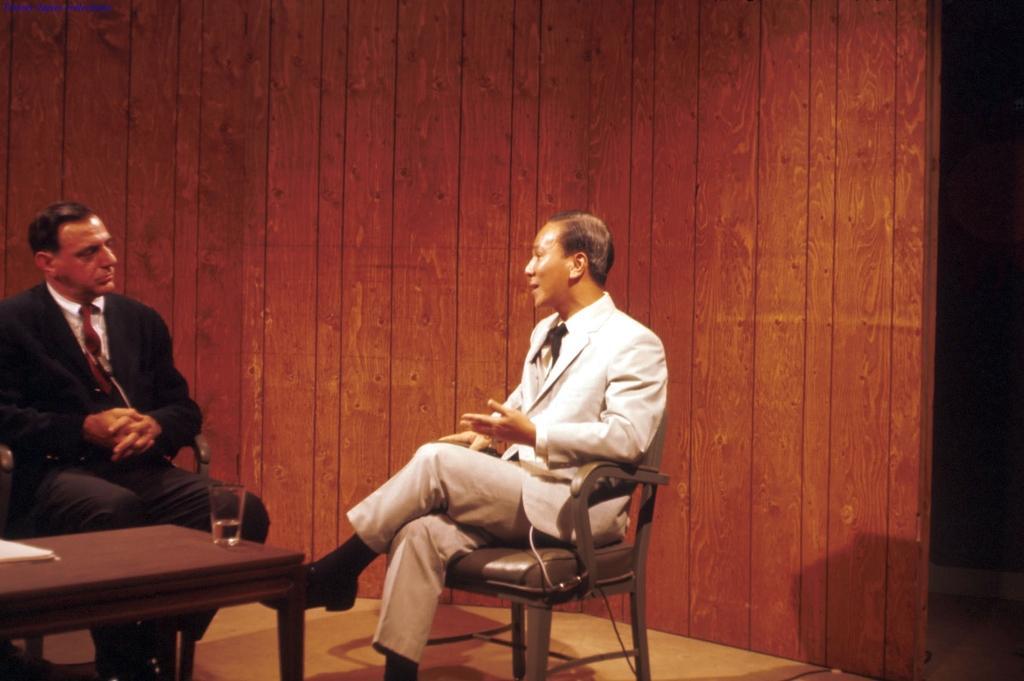Please provide a concise description of this image. Here we can see a man sitting on a wooden chair. He is wearing a suit and he is speaking. There is a man on the left side and he is also wearing a suit and looks like he is paying attention to this person. This is a wooden a table where a glass of water and papers are kept on it. 